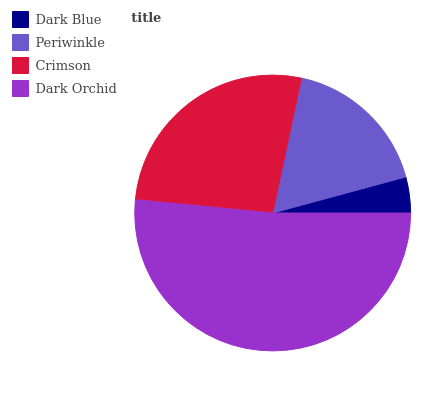Is Dark Blue the minimum?
Answer yes or no. Yes. Is Dark Orchid the maximum?
Answer yes or no. Yes. Is Periwinkle the minimum?
Answer yes or no. No. Is Periwinkle the maximum?
Answer yes or no. No. Is Periwinkle greater than Dark Blue?
Answer yes or no. Yes. Is Dark Blue less than Periwinkle?
Answer yes or no. Yes. Is Dark Blue greater than Periwinkle?
Answer yes or no. No. Is Periwinkle less than Dark Blue?
Answer yes or no. No. Is Crimson the high median?
Answer yes or no. Yes. Is Periwinkle the low median?
Answer yes or no. Yes. Is Periwinkle the high median?
Answer yes or no. No. Is Crimson the low median?
Answer yes or no. No. 